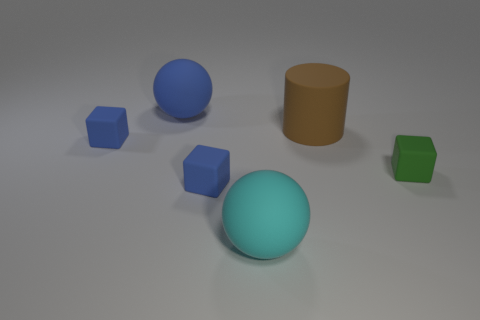Are there more balls than cyan rubber balls?
Give a very brief answer. Yes. Are any brown things visible?
Make the answer very short. Yes. What shape is the thing on the left side of the blue matte sphere on the left side of the large brown cylinder?
Keep it short and to the point. Cube. What number of things are either large blue matte spheres or small rubber cubes in front of the green cube?
Provide a succinct answer. 2. The sphere in front of the tiny blue block behind the cube that is on the right side of the brown cylinder is what color?
Provide a succinct answer. Cyan. What color is the rubber cylinder?
Your answer should be compact. Brown. What number of rubber objects are cyan balls or gray cubes?
Ensure brevity in your answer.  1. There is a tiny blue cube in front of the small blue matte block that is behind the tiny green cube; are there any large blue things to the right of it?
Your answer should be very brief. No. There is a blue sphere that is made of the same material as the green thing; what size is it?
Offer a terse response. Large. There is a big cyan matte sphere; are there any big objects behind it?
Ensure brevity in your answer.  Yes. 